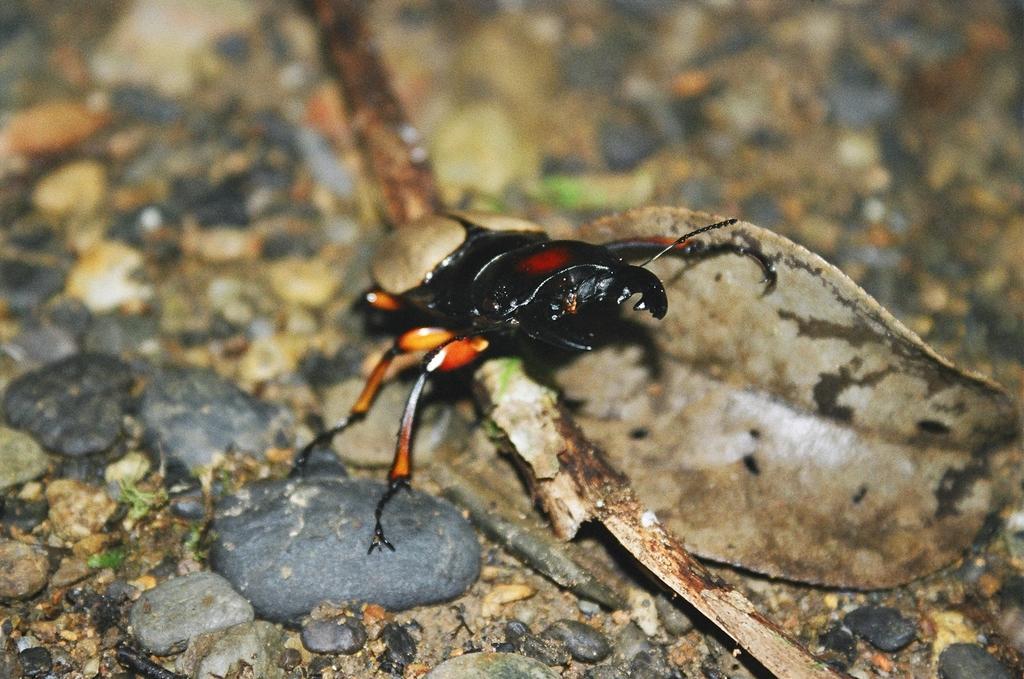How would you summarize this image in a sentence or two? This image is taken outdoors. At the bottom of the image there is a ground with pebbles and dry leaves. In the middle of the image there is an insect. 